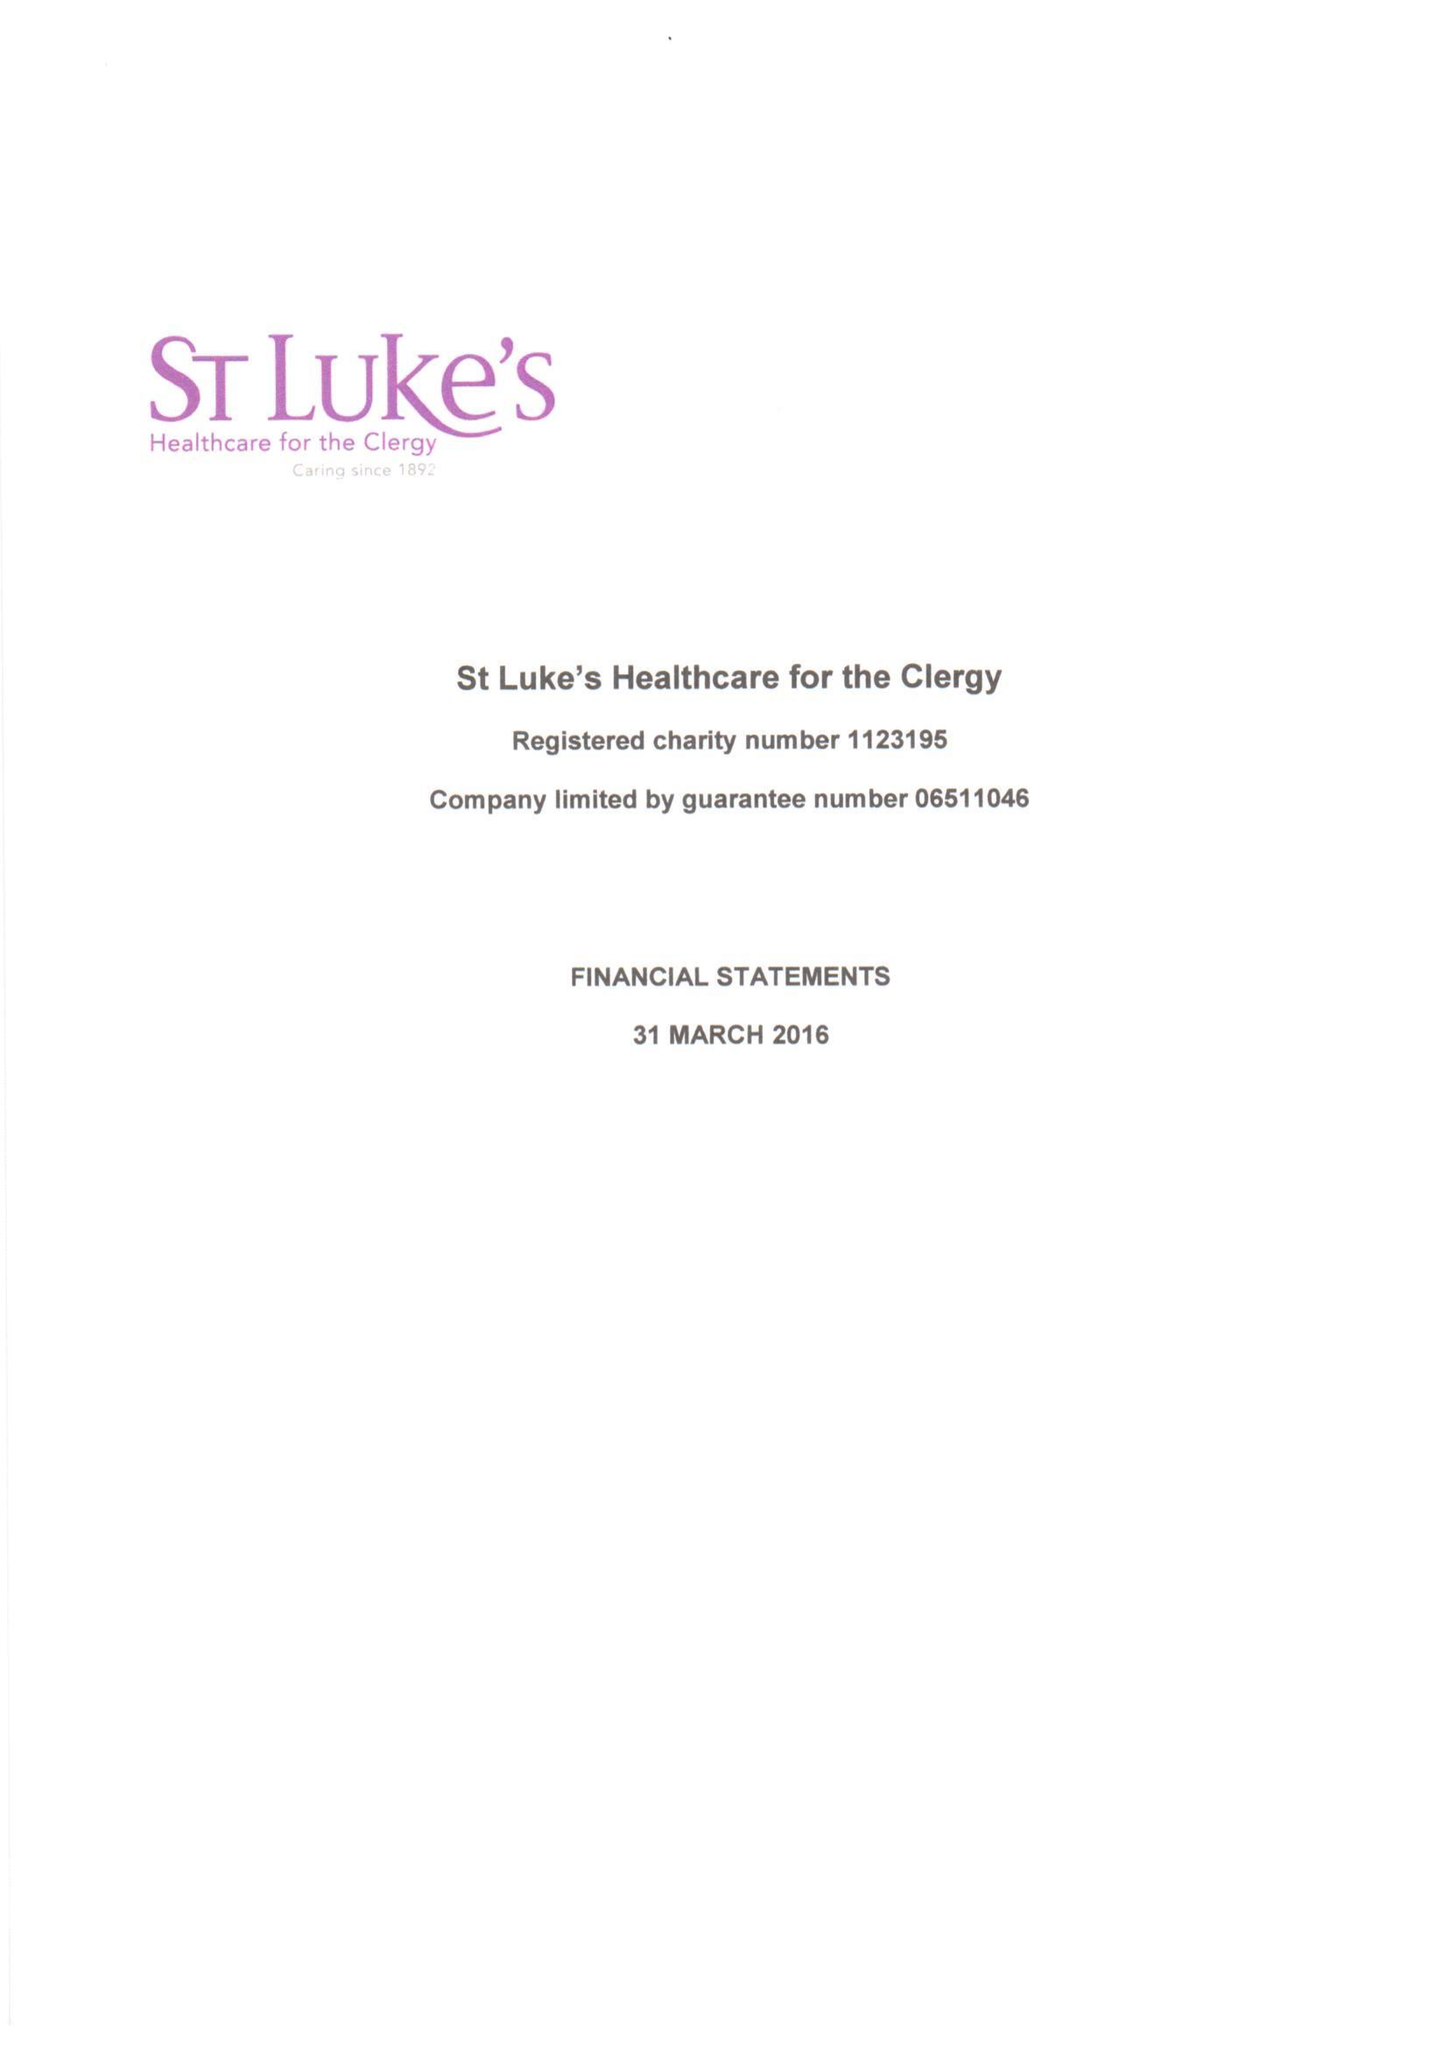What is the value for the address__street_line?
Answer the question using a single word or phrase. 27 GREAT SMITH STREET 